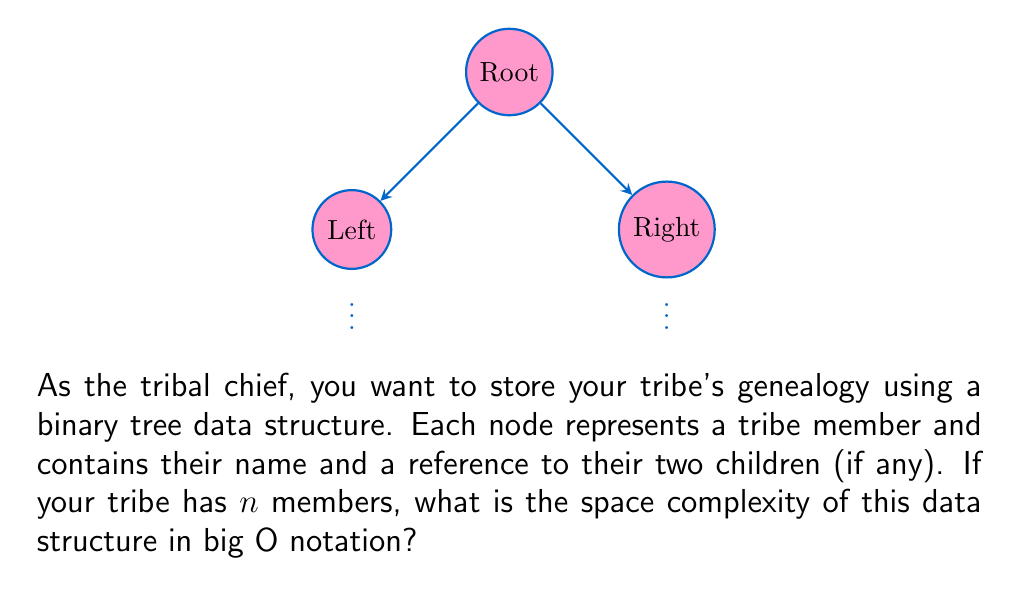Could you help me with this problem? Let's analyze the space complexity step by step:

1) Each node in the binary tree contains:
   - A name (string): Let's assume this takes constant space, $O(1)$.
   - Two references to child nodes: Each reference takes constant space, so $O(1)$ for both.

2) The total space for each node is therefore $O(1)$.

3) We have $n$ members in the tribe, so we need $n$ nodes in the tree.

4) The total space required is:
   $$ \text{Total Space} = n \times \text{Space per node} = n \times O(1) = O(n) $$

5) In the worst case (a completely unbalanced tree), the depth of the tree could be $n$, but this doesn't affect the space complexity, only the time complexity for certain operations.

6) The space complexity remains $O(n)$ regardless of the tree's shape, as we're only concerned with the total number of nodes, not their arrangement.

Therefore, the space complexity of storing the tribal genealogy using a binary tree is $O(n)$, where $n$ is the number of tribe members.
Answer: $O(n)$ 